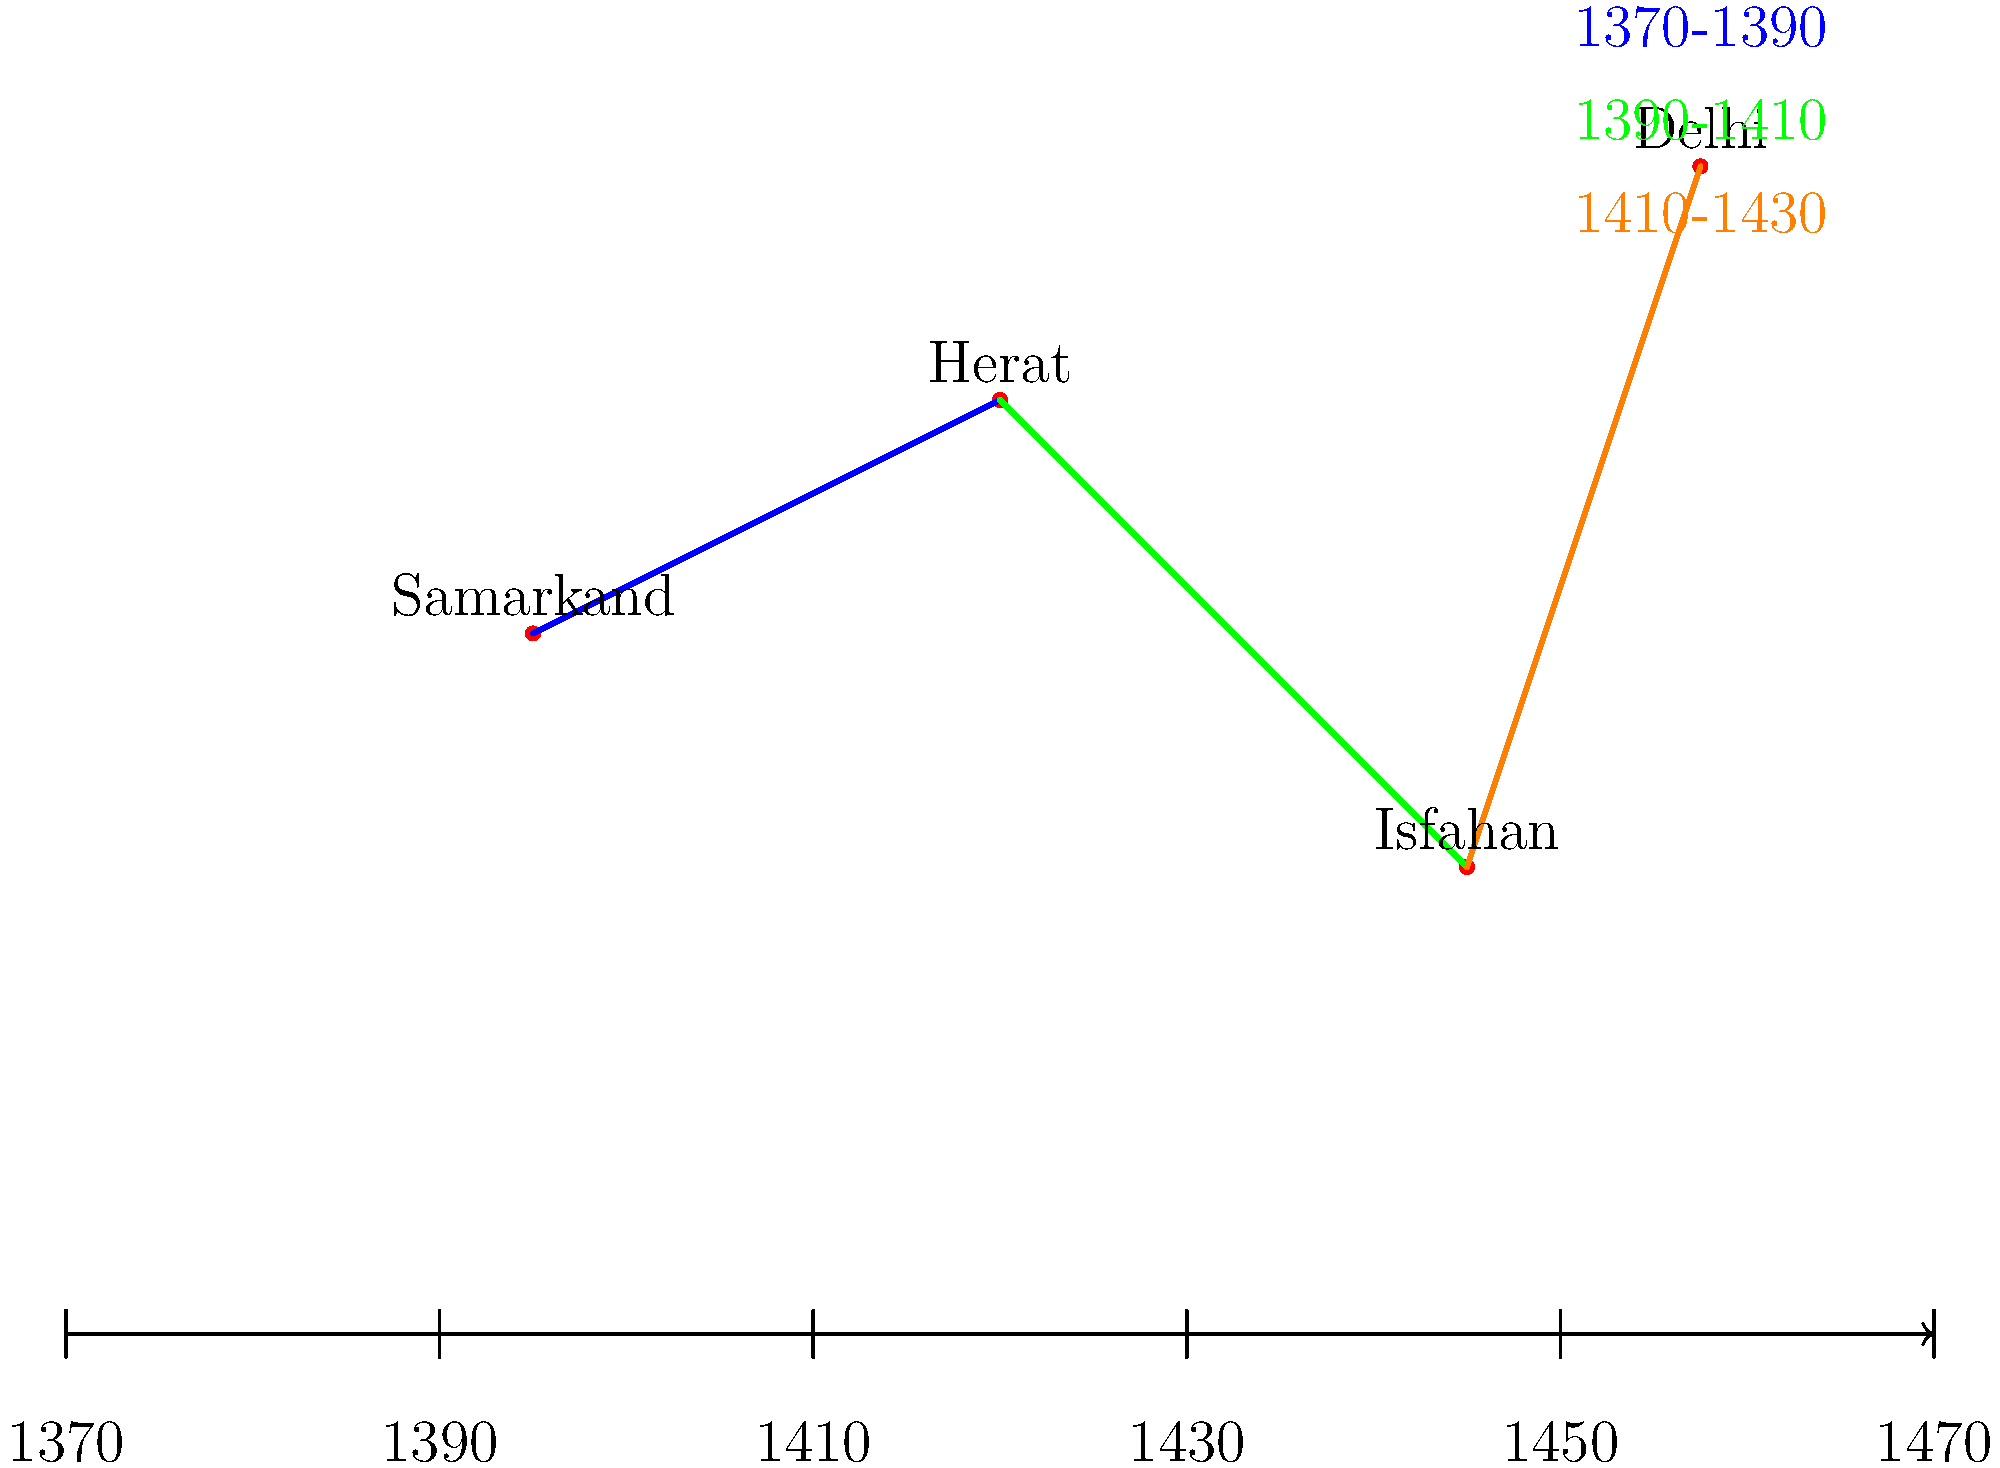Analyze the given timeline and map coordinates representing the expansion of the Timurid Empire. Which city, according to the visualization, was the last major conquest in this expansion period, and approximately when did it occur? To answer this question, we need to examine the timeline and map coordinates provided:

1. The timeline spans from 1370 to 1470, with each interval representing 20 years.

2. The map shows four cities: Samarkand, Herat, Isfahan, and Delhi.

3. The colored lines represent the expansion of the empire:
   - Blue line (1370-1390): Samarkand to Herat
   - Green line (1390-1410): Herat to Isfahan
   - Orange line (1410-1430): Isfahan to Delhi

4. Following the progression of the colored lines, we can see that Delhi is connected by the orange line, which is the last in the sequence.

5. The orange line corresponds to the period 1410-1430 on the timeline.

Therefore, Delhi appears to be the last major conquest in this expansion period, occurring approximately between 1410 and 1430.
Answer: Delhi, circa 1420 